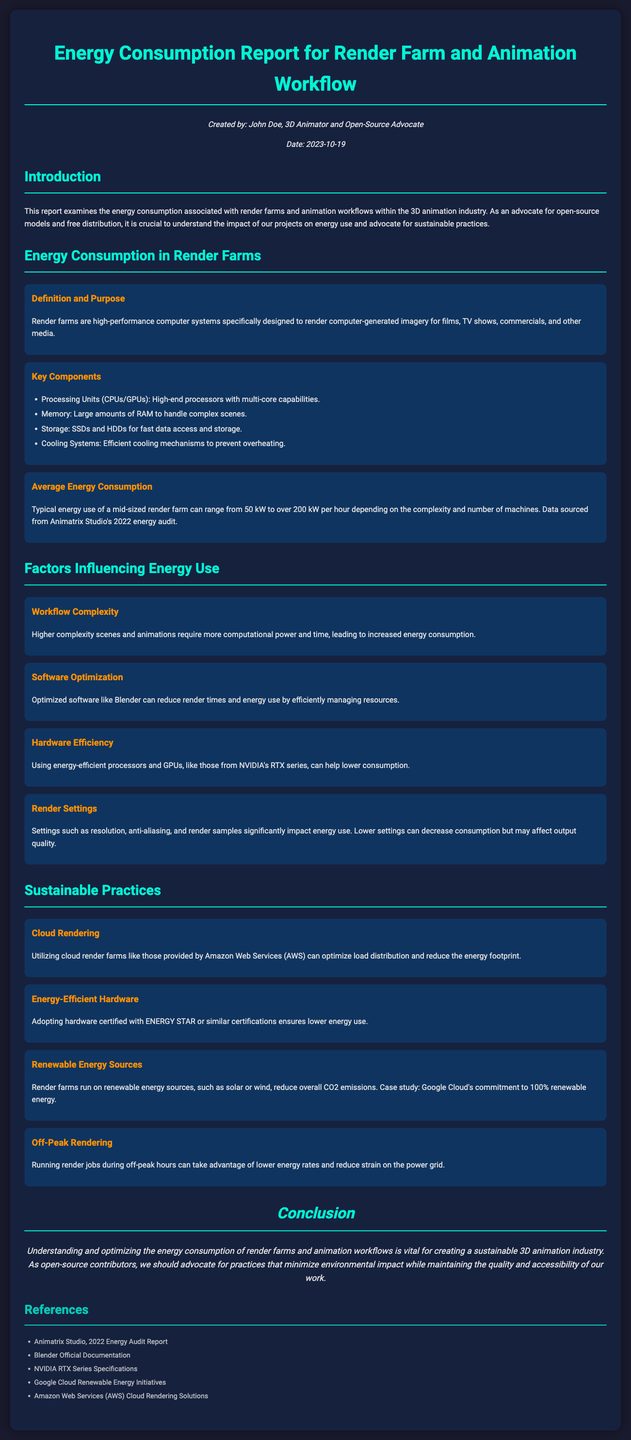What is the purpose of a render farm? A render farm is specifically designed to render computer-generated imagery for various media.
Answer: render computer-generated imagery What date was the report created? The report was created on the date indicated in the meta section.
Answer: 2023-10-19 What is the average energy consumption of a mid-sized render farm? The report states that typical energy use can range significantly as per the data provided.
Answer: 50 kW to over 200 kW per hour What factor increases energy consumption in animation workflows? Higher complexity scenes and animations lead to more computational power and time, increasing energy use.
Answer: Workflow Complexity Which hardware can help lower energy consumption? Energy-efficient processors and GPUs like those from a specific series are mentioned.
Answer: NVIDIA's RTX series What sustainable practice involves using renewable energy sources? This practice helps in reducing overall CO2 emissions for rendering.
Answer: Renewable Energy Sources What software is mentioned as a way to reduce render times and energy use? The software that effectively manages resources and optimizes rendering is named in the document.
Answer: Blender What should be adopted to ensure lower energy use according to the report? The report recommends certification for hardware to ensure energy efficiency.
Answer: ENERGY STAR What is suggested for rendering jobs to lower energy rates? Running jobs during specific times can take advantage of lower costs and reduce strain.
Answer: Off-Peak Rendering 